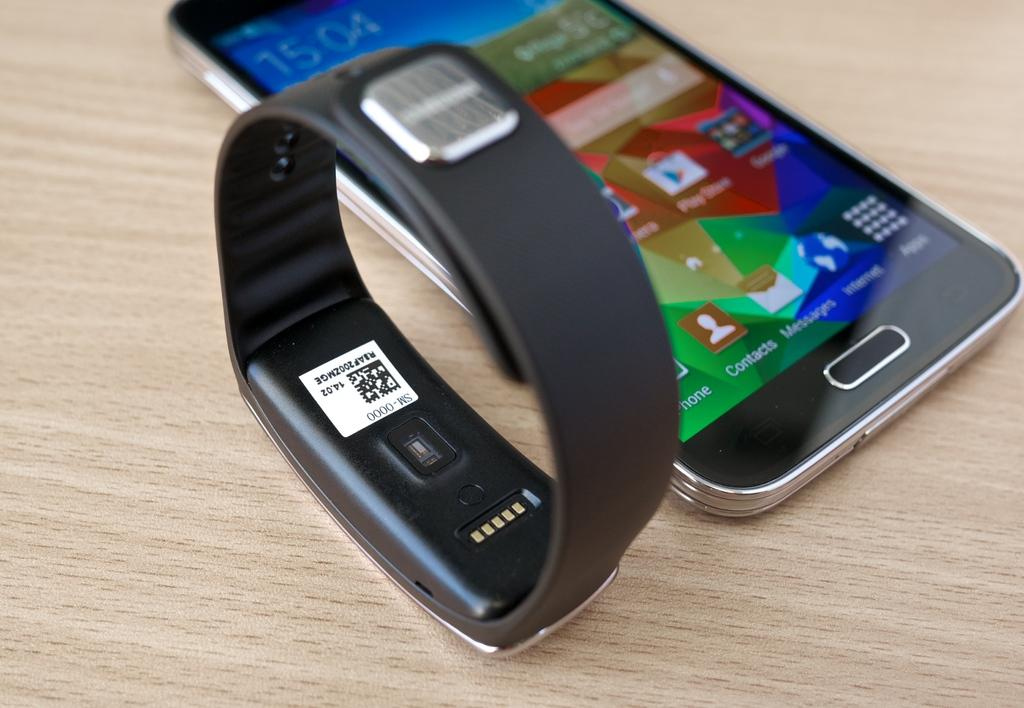<image>
Summarize the visual content of the image. A smart watch band beside a black smartphone with the time 15:04 on the screen 